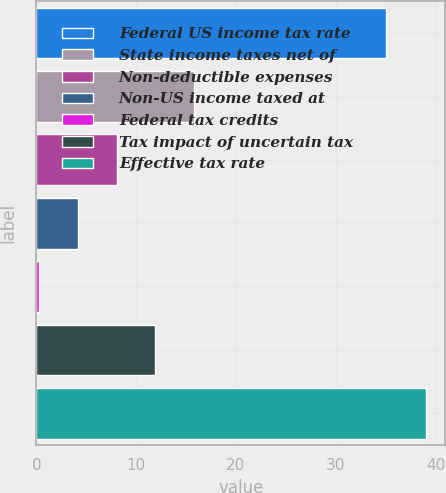Convert chart. <chart><loc_0><loc_0><loc_500><loc_500><bar_chart><fcel>Federal US income tax rate<fcel>State income taxes net of<fcel>Non-deductible expenses<fcel>Non-US income taxed at<fcel>Federal tax credits<fcel>Tax impact of uncertain tax<fcel>Effective tax rate<nl><fcel>35<fcel>15.78<fcel>8.04<fcel>4.17<fcel>0.3<fcel>11.91<fcel>39<nl></chart> 